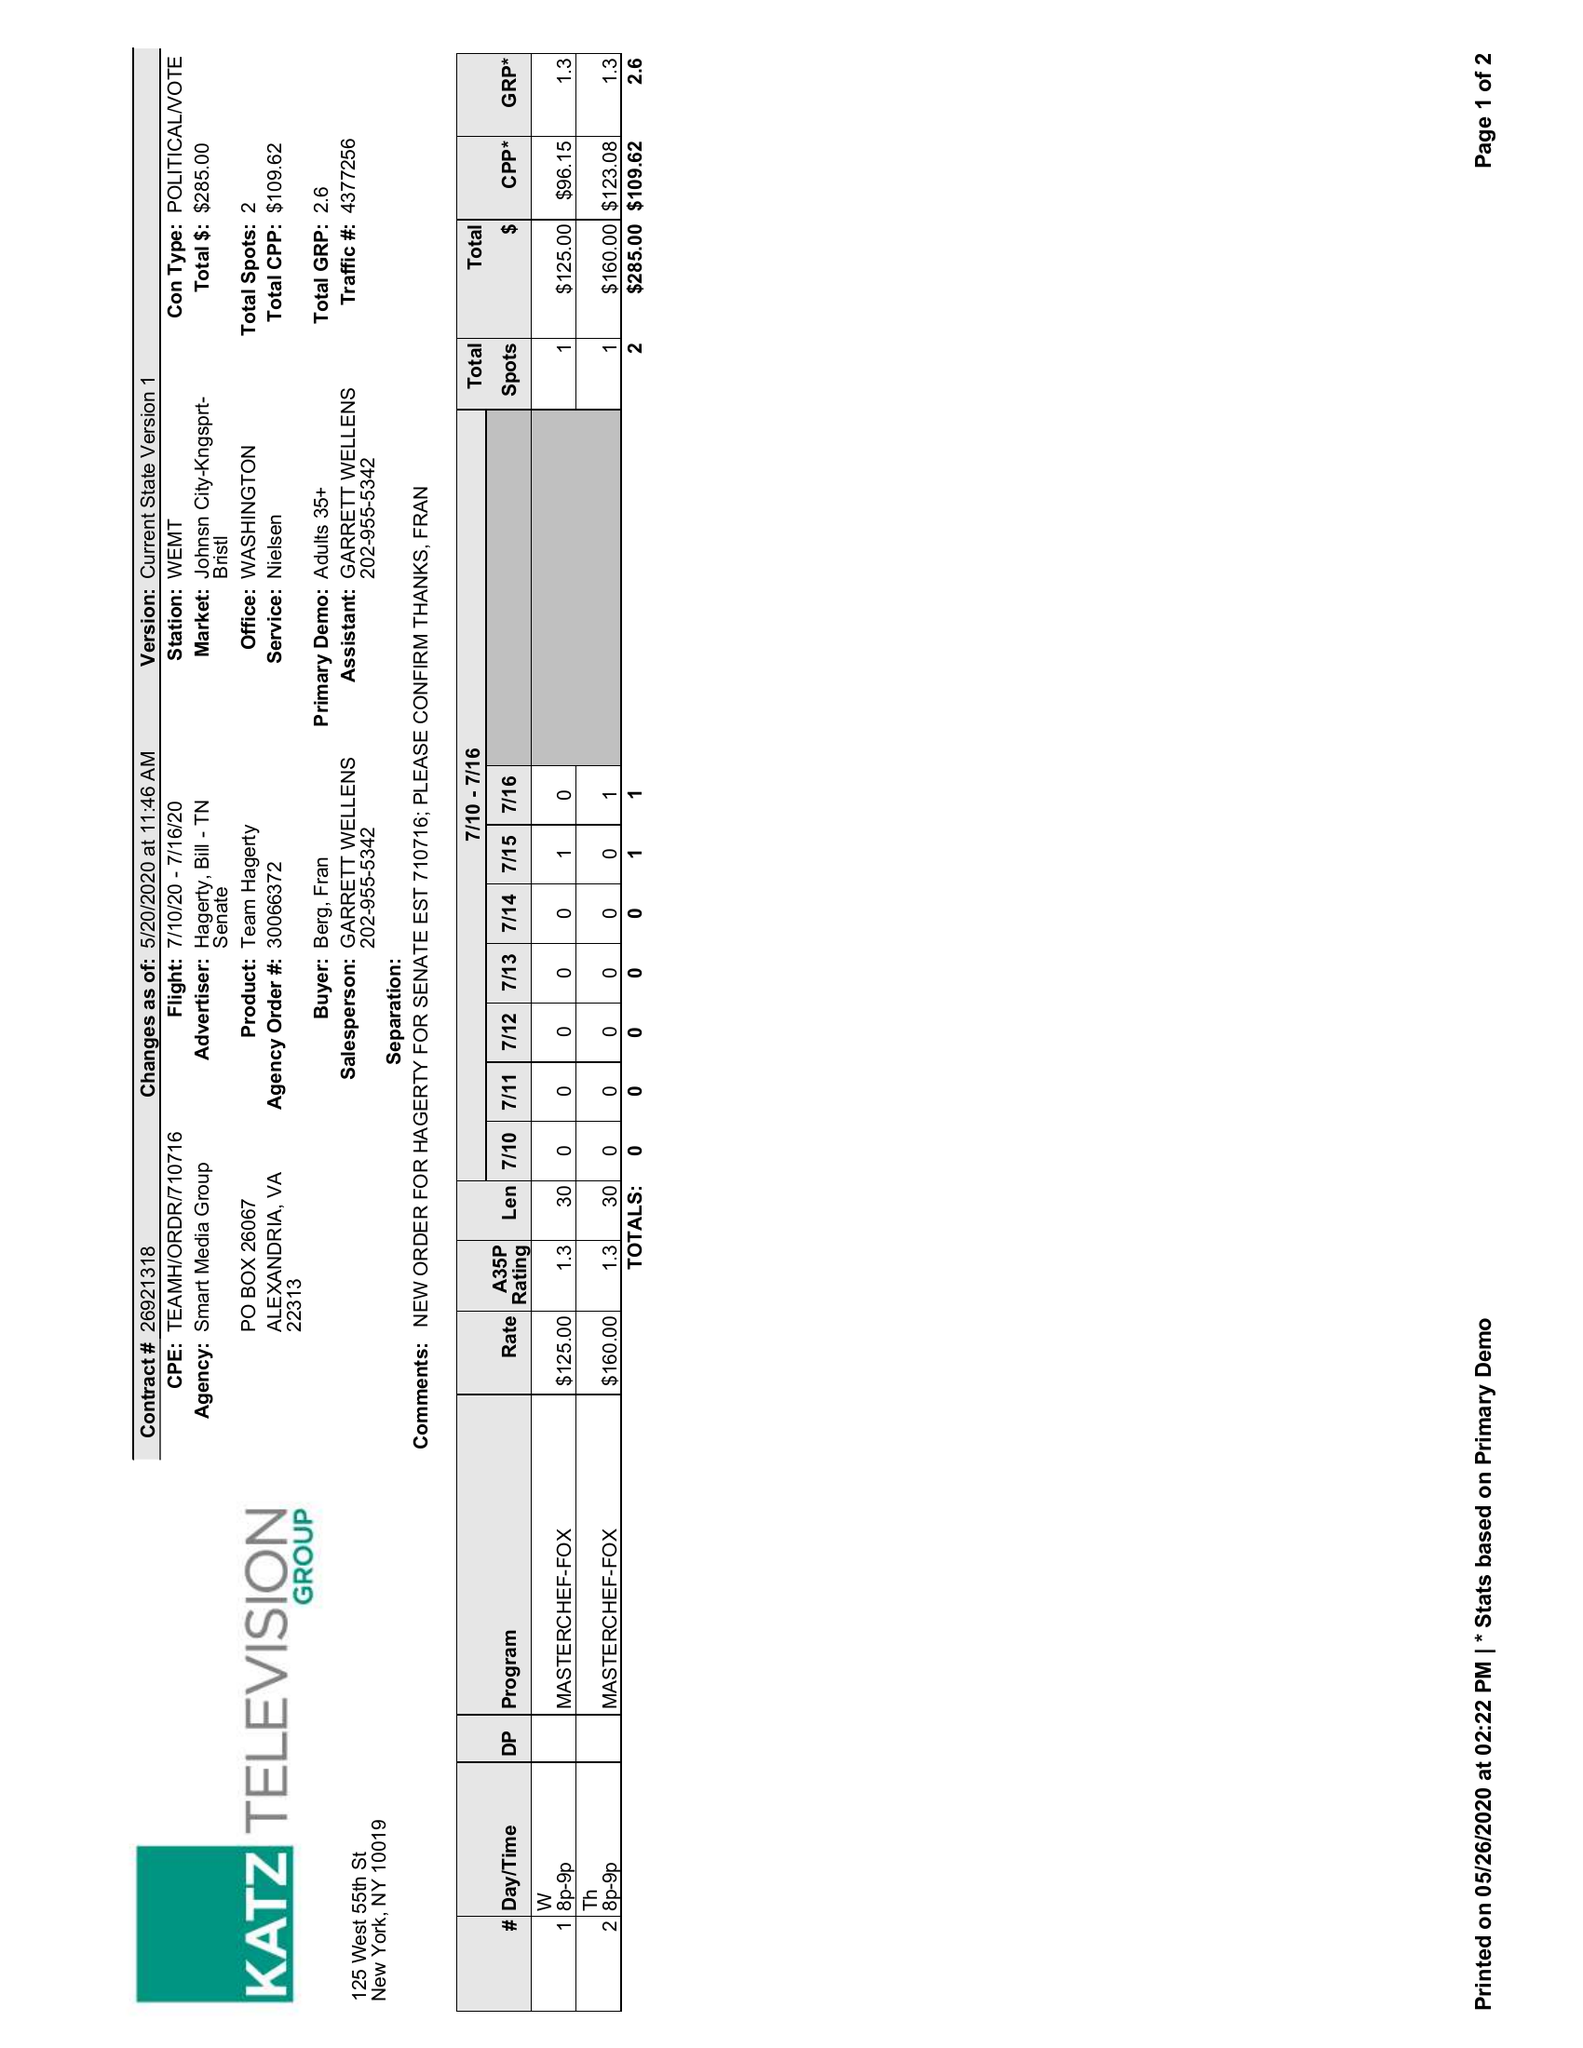What is the value for the advertiser?
Answer the question using a single word or phrase. HAGERTY, BILL - TN SENATE 